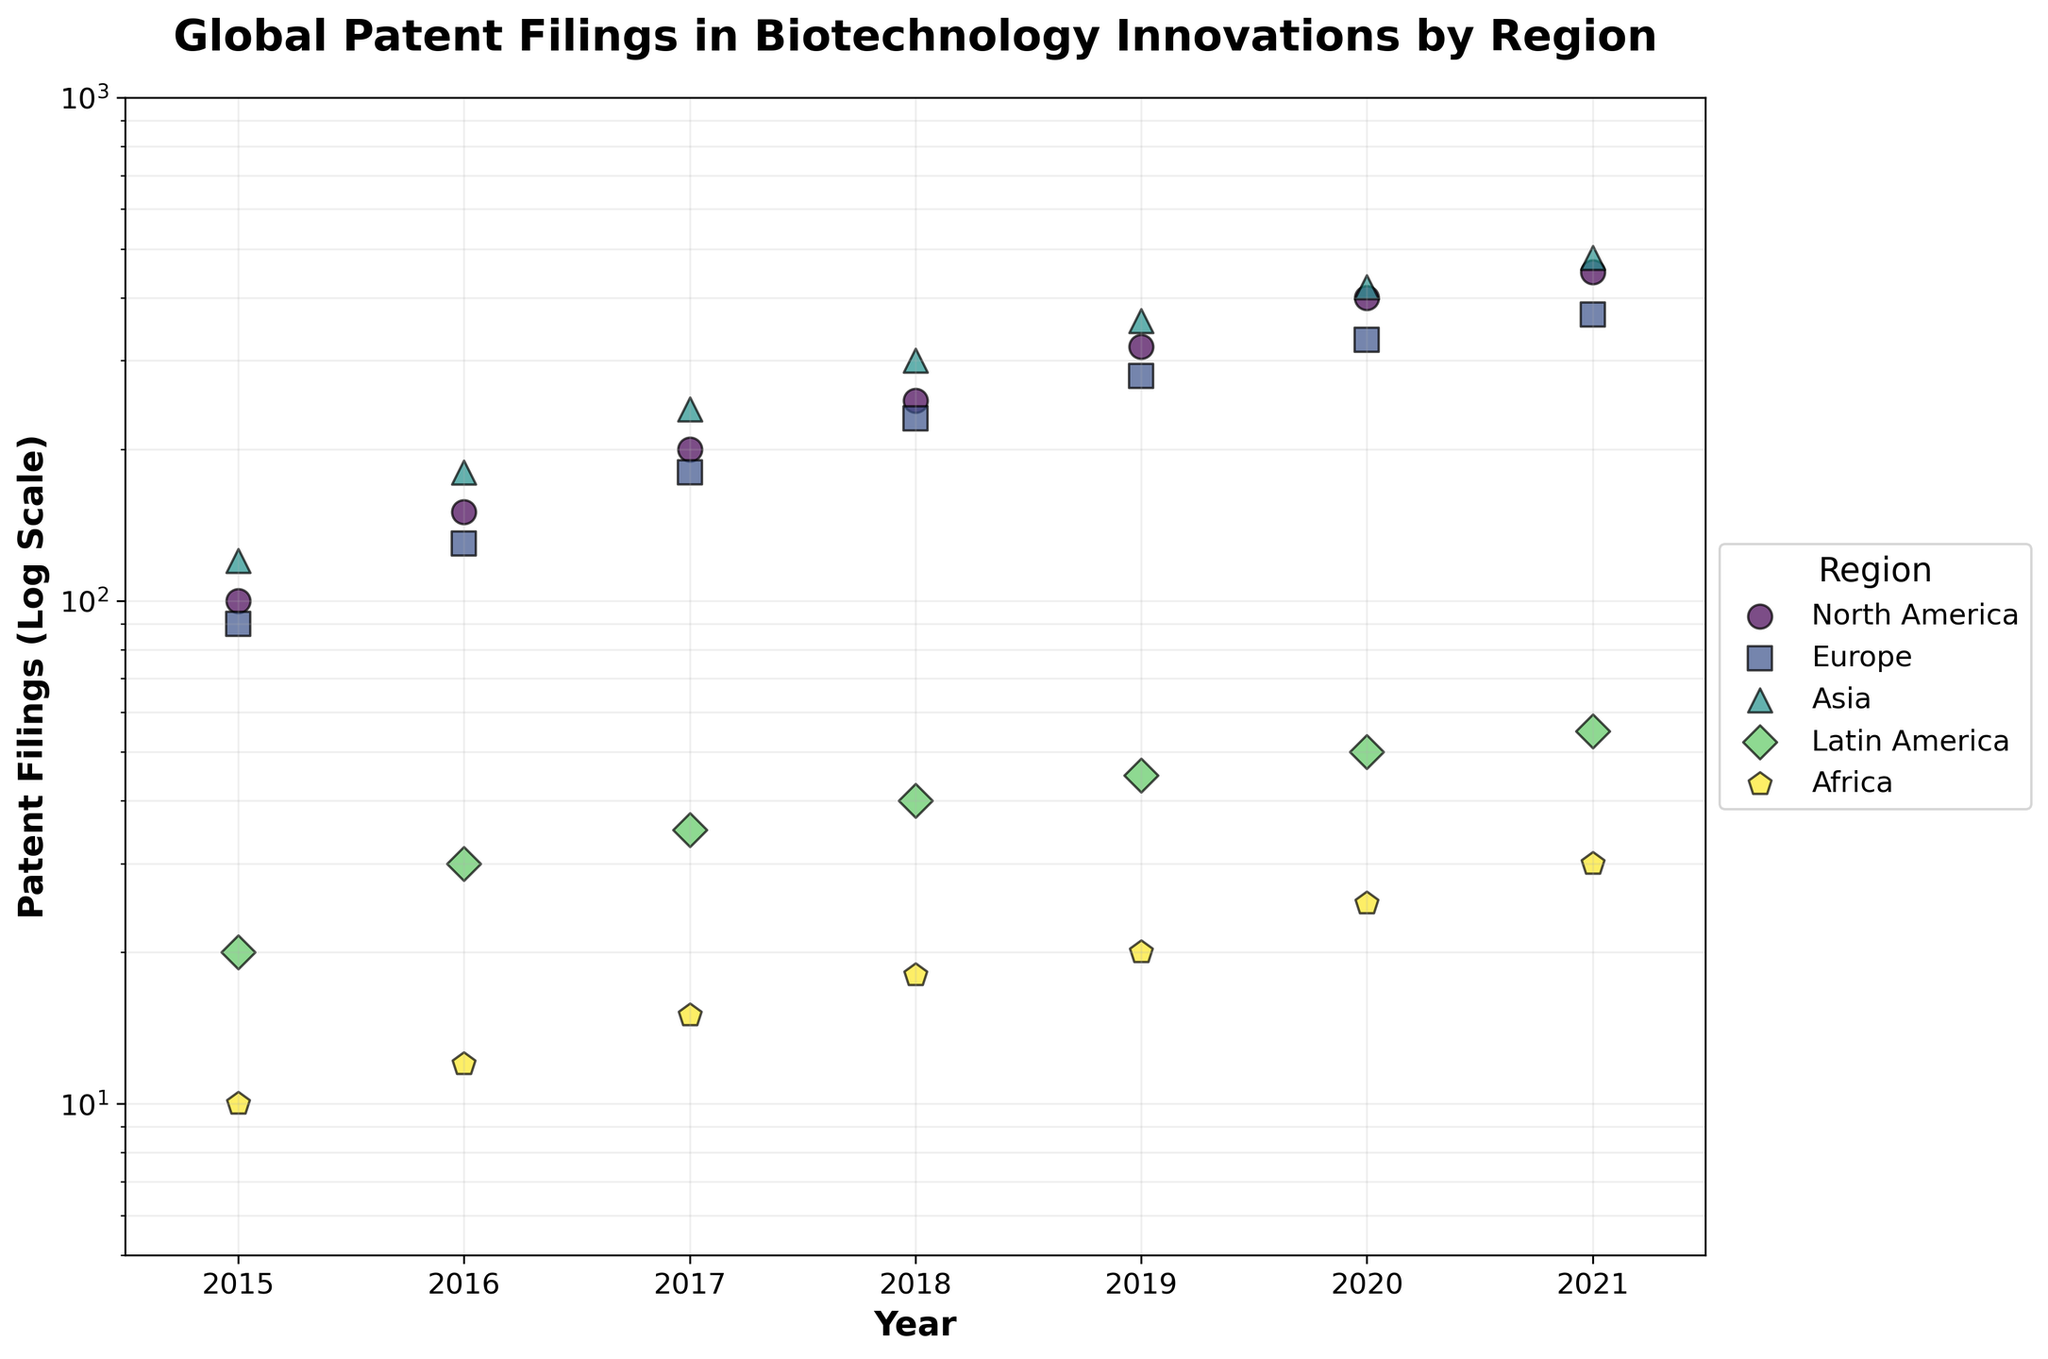What is the title of the scatter plot? The title is usually at the top of the plot and provides a brief description of what the plot is about.
Answer: Global Patent Filings in Biotechnology Innovations by Region Which region has the highest number of patent filings in 2021? Look for the region where the data point at the year 2021 is at the highest position on the y-axis.
Answer: Asia Approximately how many patent filings were made by North America in 2020? Find the data point labeled "North America" for the year 2020 on the x-axis and read the corresponding y-axis value.
Answer: 400 How does the number of patent filings in Europe in 2018 compare to those in North America in the same year? Identify the points for Europe and North America in the year 2018, then compare their positions on the y-axis.
Answer: Europe: 230, North America: 250 Which region demonstrated the most significant growth in patent filings between 2015 and 2021? Calculate the difference in patent filings between 2021 and 2015 for all regions and identify the largest difference.
Answer: Asia What is the average number of patent filings in Asia from 2015 to 2021? Add the number of patent filings for Asia from each year (2015 to 2021) and divide by the number of years. (120 + 180 + 240 + 300 + 360 + 420 + 480) / 7 = 300
Answer: 300 What trend is observed in patent filings in Latin America from 2015 to 2021? Examine the data points for Latin America from 2015 to 2021 and describe the visible pattern.
Answer: Gradual increase How many regions had fewer than 50 patent filings in 2021? Find the number of regions whose data point for the year 2021 is below the 50 mark on the y-axis.
Answer: 2 (Latin America and Africa) By what factor did the number of patent filings in Africa change from 2015 to 2021? Divide the number of patent filings in 2021 by the number in 2015 for Africa. 30 / 10 = 3
Answer: 3 In which year did Europe surpass 300 patent filings? Locate the point where Europe's filings exceed the 300 mark on the y-axis and read the corresponding year on the x-axis.
Answer: 2021 